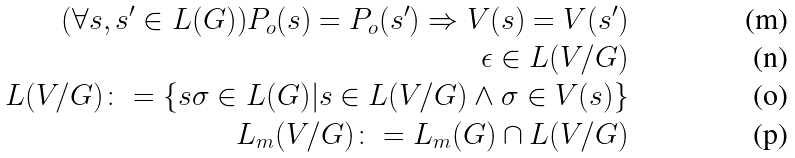<formula> <loc_0><loc_0><loc_500><loc_500>( \forall s , s ^ { \prime } \in L ( G ) ) P _ { o } ( s ) = P _ { o } ( s ^ { \prime } ) \Rightarrow V ( s ) = V ( s ^ { \prime } ) \\ \epsilon \in L ( V / G ) \\ L ( V / G ) \colon = \{ s \sigma \in L ( G ) | s \in L ( V / G ) \wedge \sigma \in V ( s ) \} \\ L _ { m } ( V / G ) \colon = L _ { m } ( G ) \cap L ( V / G )</formula> 